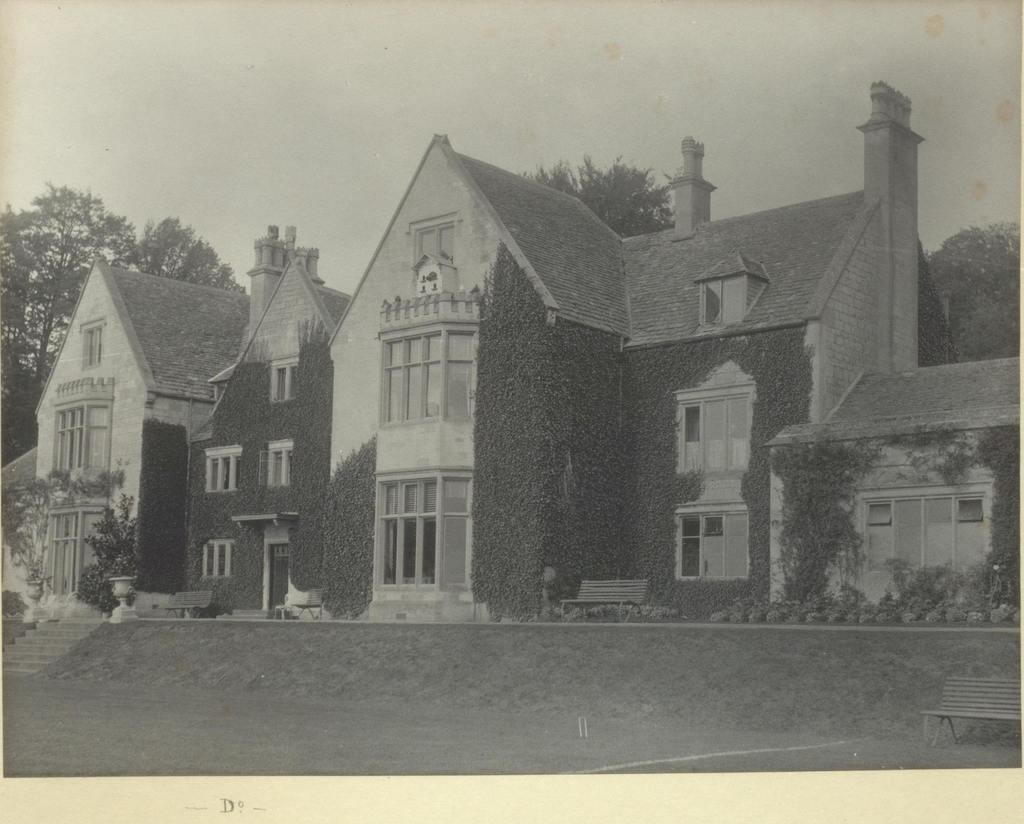Could you give a brief overview of what you see in this image? This is a black and white picture. In the center of the picture there are trees and a building. 